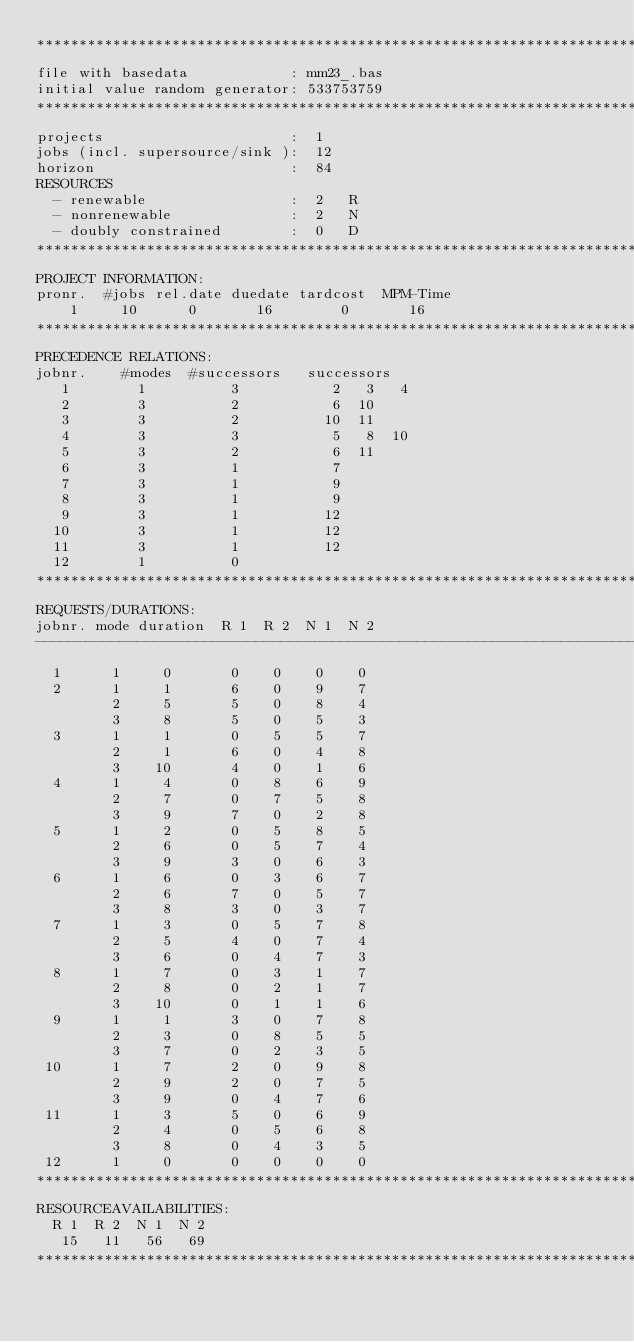Convert code to text. <code><loc_0><loc_0><loc_500><loc_500><_ObjectiveC_>************************************************************************
file with basedata            : mm23_.bas
initial value random generator: 533753759
************************************************************************
projects                      :  1
jobs (incl. supersource/sink ):  12
horizon                       :  84
RESOURCES
  - renewable                 :  2   R
  - nonrenewable              :  2   N
  - doubly constrained        :  0   D
************************************************************************
PROJECT INFORMATION:
pronr.  #jobs rel.date duedate tardcost  MPM-Time
    1     10      0       16        0       16
************************************************************************
PRECEDENCE RELATIONS:
jobnr.    #modes  #successors   successors
   1        1          3           2   3   4
   2        3          2           6  10
   3        3          2          10  11
   4        3          3           5   8  10
   5        3          2           6  11
   6        3          1           7
   7        3          1           9
   8        3          1           9
   9        3          1          12
  10        3          1          12
  11        3          1          12
  12        1          0        
************************************************************************
REQUESTS/DURATIONS:
jobnr. mode duration  R 1  R 2  N 1  N 2
------------------------------------------------------------------------
  1      1     0       0    0    0    0
  2      1     1       6    0    9    7
         2     5       5    0    8    4
         3     8       5    0    5    3
  3      1     1       0    5    5    7
         2     1       6    0    4    8
         3    10       4    0    1    6
  4      1     4       0    8    6    9
         2     7       0    7    5    8
         3     9       7    0    2    8
  5      1     2       0    5    8    5
         2     6       0    5    7    4
         3     9       3    0    6    3
  6      1     6       0    3    6    7
         2     6       7    0    5    7
         3     8       3    0    3    7
  7      1     3       0    5    7    8
         2     5       4    0    7    4
         3     6       0    4    7    3
  8      1     7       0    3    1    7
         2     8       0    2    1    7
         3    10       0    1    1    6
  9      1     1       3    0    7    8
         2     3       0    8    5    5
         3     7       0    2    3    5
 10      1     7       2    0    9    8
         2     9       2    0    7    5
         3     9       0    4    7    6
 11      1     3       5    0    6    9
         2     4       0    5    6    8
         3     8       0    4    3    5
 12      1     0       0    0    0    0
************************************************************************
RESOURCEAVAILABILITIES:
  R 1  R 2  N 1  N 2
   15   11   56   69
************************************************************************
</code> 